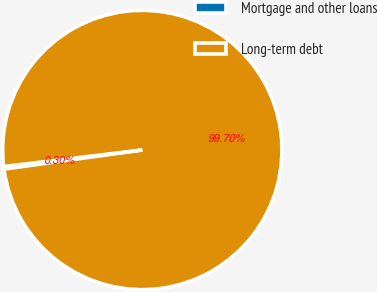Convert chart. <chart><loc_0><loc_0><loc_500><loc_500><pie_chart><fcel>Mortgage and other loans<fcel>Long-term debt<nl><fcel>0.3%<fcel>99.7%<nl></chart> 